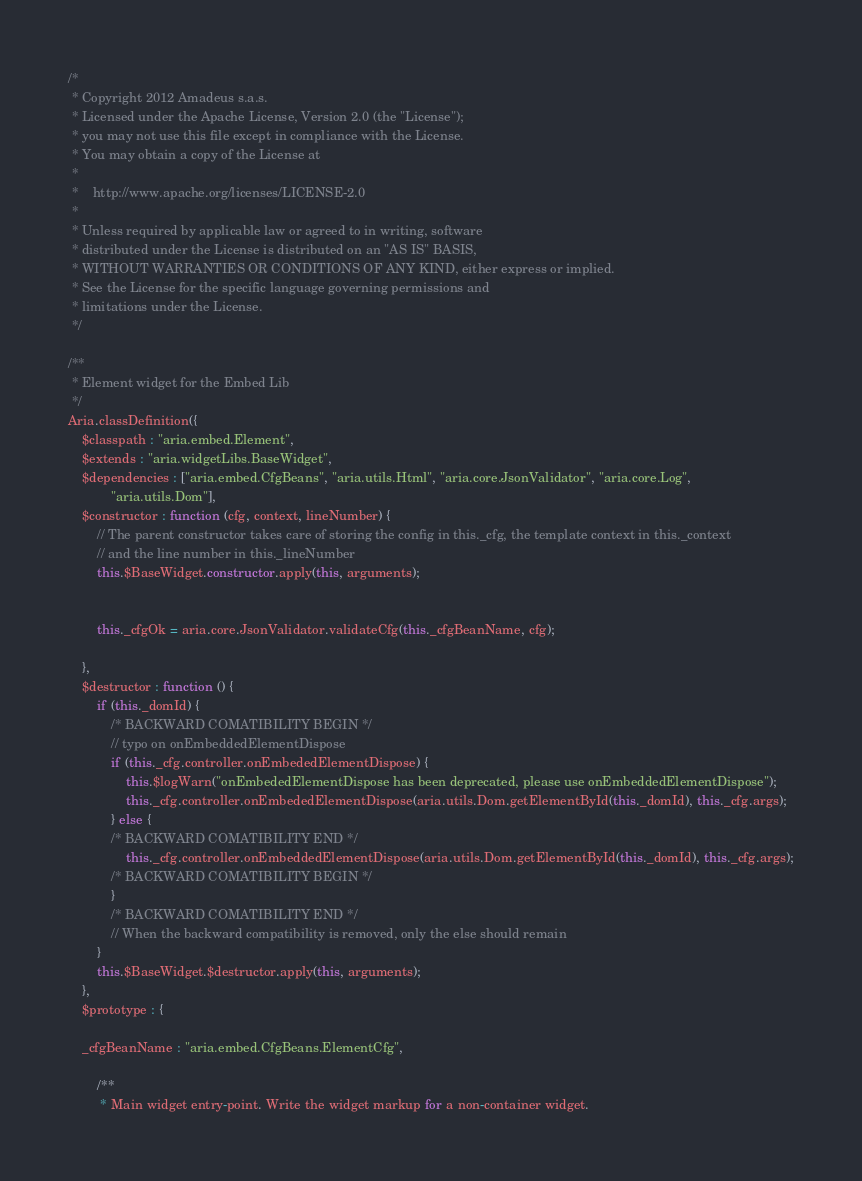Convert code to text. <code><loc_0><loc_0><loc_500><loc_500><_JavaScript_>/*
 * Copyright 2012 Amadeus s.a.s.
 * Licensed under the Apache License, Version 2.0 (the "License");
 * you may not use this file except in compliance with the License.
 * You may obtain a copy of the License at
 *
 *    http://www.apache.org/licenses/LICENSE-2.0
 *
 * Unless required by applicable law or agreed to in writing, software
 * distributed under the License is distributed on an "AS IS" BASIS,
 * WITHOUT WARRANTIES OR CONDITIONS OF ANY KIND, either express or implied.
 * See the License for the specific language governing permissions and
 * limitations under the License.
 */

/**
 * Element widget for the Embed Lib
 */
Aria.classDefinition({
    $classpath : "aria.embed.Element",
    $extends : "aria.widgetLibs.BaseWidget",
    $dependencies : ["aria.embed.CfgBeans", "aria.utils.Html", "aria.core.JsonValidator", "aria.core.Log",
            "aria.utils.Dom"],
    $constructor : function (cfg, context, lineNumber) {
        // The parent constructor takes care of storing the config in this._cfg, the template context in this._context
        // and the line number in this._lineNumber
        this.$BaseWidget.constructor.apply(this, arguments);


        this._cfgOk = aria.core.JsonValidator.validateCfg(this._cfgBeanName, cfg);

    },
    $destructor : function () {
        if (this._domId) {
            /* BACKWARD COMATIBILITY BEGIN */
            // typo on onEmbeddedElementDispose
            if (this._cfg.controller.onEmbededElementDispose) {
                this.$logWarn("onEmbededElementDispose has been deprecated, please use onEmbeddedElementDispose");
                this._cfg.controller.onEmbededElementDispose(aria.utils.Dom.getElementById(this._domId), this._cfg.args);
            } else {
            /* BACKWARD COMATIBILITY END */
                this._cfg.controller.onEmbeddedElementDispose(aria.utils.Dom.getElementById(this._domId), this._cfg.args);
            /* BACKWARD COMATIBILITY BEGIN */
            }
            /* BACKWARD COMATIBILITY END */
            // When the backward compatibility is removed, only the else should remain
        }
        this.$BaseWidget.$destructor.apply(this, arguments);
    },
    $prototype : {

    _cfgBeanName : "aria.embed.CfgBeans.ElementCfg",

        /**
         * Main widget entry-point. Write the widget markup for a non-container widget.</code> 